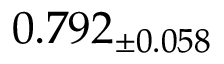Convert formula to latex. <formula><loc_0><loc_0><loc_500><loc_500>0 . 7 9 2 _ { \pm 0 . 0 5 8 }</formula> 